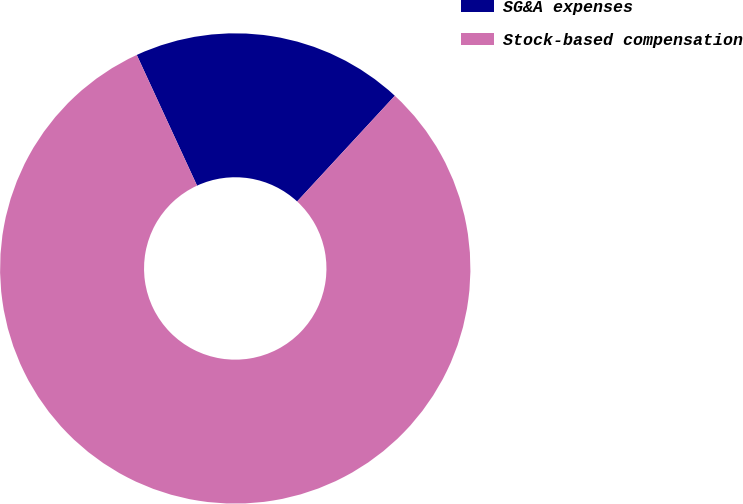Convert chart. <chart><loc_0><loc_0><loc_500><loc_500><pie_chart><fcel>SG&A expenses<fcel>Stock-based compensation<nl><fcel>18.75%<fcel>81.25%<nl></chart> 